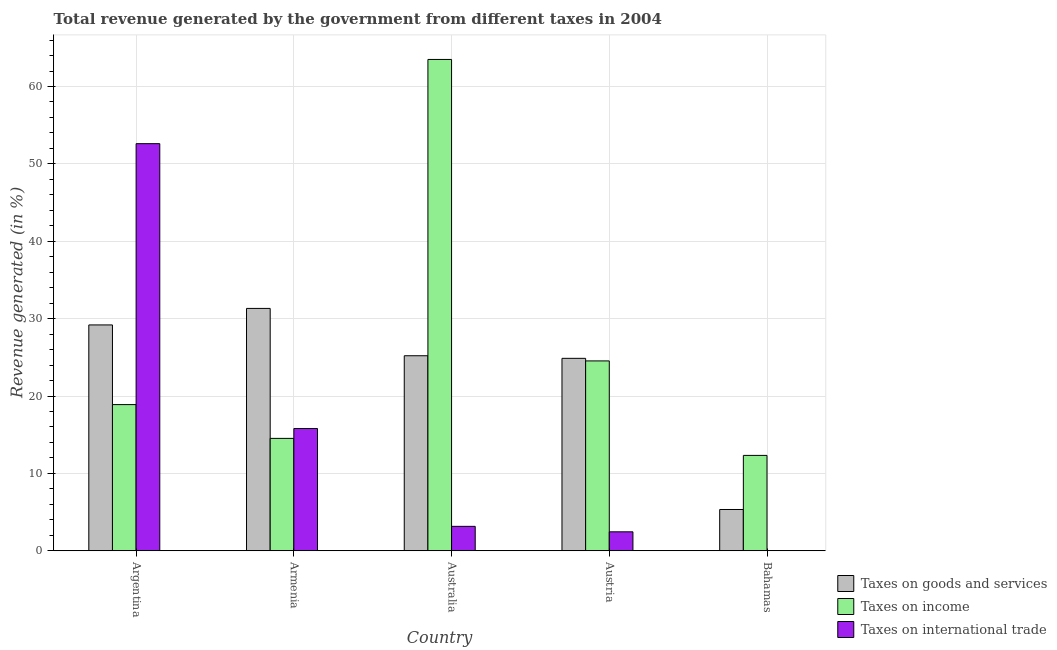How many different coloured bars are there?
Provide a short and direct response. 3. How many groups of bars are there?
Provide a short and direct response. 5. Are the number of bars per tick equal to the number of legend labels?
Offer a very short reply. Yes. Are the number of bars on each tick of the X-axis equal?
Your response must be concise. Yes. How many bars are there on the 3rd tick from the left?
Provide a succinct answer. 3. What is the label of the 2nd group of bars from the left?
Keep it short and to the point. Armenia. In how many cases, is the number of bars for a given country not equal to the number of legend labels?
Ensure brevity in your answer.  0. What is the percentage of revenue generated by taxes on income in Bahamas?
Give a very brief answer. 12.33. Across all countries, what is the maximum percentage of revenue generated by taxes on goods and services?
Provide a succinct answer. 31.32. Across all countries, what is the minimum percentage of revenue generated by taxes on goods and services?
Ensure brevity in your answer.  5.33. In which country was the percentage of revenue generated by taxes on income minimum?
Keep it short and to the point. Bahamas. What is the total percentage of revenue generated by tax on international trade in the graph?
Provide a short and direct response. 74.02. What is the difference between the percentage of revenue generated by taxes on goods and services in Armenia and that in Austria?
Keep it short and to the point. 6.45. What is the difference between the percentage of revenue generated by taxes on income in Australia and the percentage of revenue generated by tax on international trade in Argentina?
Offer a very short reply. 10.88. What is the average percentage of revenue generated by taxes on goods and services per country?
Your response must be concise. 23.18. What is the difference between the percentage of revenue generated by tax on international trade and percentage of revenue generated by taxes on income in Austria?
Make the answer very short. -22.09. What is the ratio of the percentage of revenue generated by taxes on income in Australia to that in Austria?
Make the answer very short. 2.59. Is the difference between the percentage of revenue generated by taxes on income in Argentina and Austria greater than the difference between the percentage of revenue generated by tax on international trade in Argentina and Austria?
Provide a succinct answer. No. What is the difference between the highest and the second highest percentage of revenue generated by tax on international trade?
Your response must be concise. 36.81. What is the difference between the highest and the lowest percentage of revenue generated by taxes on income?
Keep it short and to the point. 51.17. What does the 2nd bar from the left in Argentina represents?
Keep it short and to the point. Taxes on income. What does the 1st bar from the right in Austria represents?
Your response must be concise. Taxes on international trade. Is it the case that in every country, the sum of the percentage of revenue generated by taxes on goods and services and percentage of revenue generated by taxes on income is greater than the percentage of revenue generated by tax on international trade?
Your answer should be compact. No. How many bars are there?
Offer a terse response. 15. What is the difference between two consecutive major ticks on the Y-axis?
Give a very brief answer. 10. Are the values on the major ticks of Y-axis written in scientific E-notation?
Ensure brevity in your answer.  No. Does the graph contain any zero values?
Make the answer very short. No. Where does the legend appear in the graph?
Provide a succinct answer. Bottom right. What is the title of the graph?
Keep it short and to the point. Total revenue generated by the government from different taxes in 2004. What is the label or title of the X-axis?
Your response must be concise. Country. What is the label or title of the Y-axis?
Provide a short and direct response. Revenue generated (in %). What is the Revenue generated (in %) of Taxes on goods and services in Argentina?
Make the answer very short. 29.19. What is the Revenue generated (in %) of Taxes on income in Argentina?
Give a very brief answer. 18.89. What is the Revenue generated (in %) in Taxes on international trade in Argentina?
Keep it short and to the point. 52.61. What is the Revenue generated (in %) in Taxes on goods and services in Armenia?
Make the answer very short. 31.32. What is the Revenue generated (in %) of Taxes on income in Armenia?
Your answer should be very brief. 14.52. What is the Revenue generated (in %) of Taxes on international trade in Armenia?
Offer a terse response. 15.8. What is the Revenue generated (in %) of Taxes on goods and services in Australia?
Give a very brief answer. 25.2. What is the Revenue generated (in %) of Taxes on income in Australia?
Your answer should be compact. 63.5. What is the Revenue generated (in %) of Taxes on international trade in Australia?
Your answer should be compact. 3.16. What is the Revenue generated (in %) of Taxes on goods and services in Austria?
Your answer should be compact. 24.87. What is the Revenue generated (in %) in Taxes on income in Austria?
Provide a short and direct response. 24.54. What is the Revenue generated (in %) of Taxes on international trade in Austria?
Provide a short and direct response. 2.45. What is the Revenue generated (in %) in Taxes on goods and services in Bahamas?
Ensure brevity in your answer.  5.33. What is the Revenue generated (in %) in Taxes on income in Bahamas?
Ensure brevity in your answer.  12.33. What is the Revenue generated (in %) in Taxes on international trade in Bahamas?
Give a very brief answer. 0. Across all countries, what is the maximum Revenue generated (in %) in Taxes on goods and services?
Provide a short and direct response. 31.32. Across all countries, what is the maximum Revenue generated (in %) in Taxes on income?
Your response must be concise. 63.5. Across all countries, what is the maximum Revenue generated (in %) of Taxes on international trade?
Give a very brief answer. 52.61. Across all countries, what is the minimum Revenue generated (in %) in Taxes on goods and services?
Make the answer very short. 5.33. Across all countries, what is the minimum Revenue generated (in %) of Taxes on income?
Your response must be concise. 12.33. Across all countries, what is the minimum Revenue generated (in %) in Taxes on international trade?
Provide a succinct answer. 0. What is the total Revenue generated (in %) of Taxes on goods and services in the graph?
Your answer should be very brief. 115.92. What is the total Revenue generated (in %) in Taxes on income in the graph?
Give a very brief answer. 133.77. What is the total Revenue generated (in %) in Taxes on international trade in the graph?
Make the answer very short. 74.02. What is the difference between the Revenue generated (in %) in Taxes on goods and services in Argentina and that in Armenia?
Ensure brevity in your answer.  -2.13. What is the difference between the Revenue generated (in %) in Taxes on income in Argentina and that in Armenia?
Provide a short and direct response. 4.37. What is the difference between the Revenue generated (in %) of Taxes on international trade in Argentina and that in Armenia?
Make the answer very short. 36.81. What is the difference between the Revenue generated (in %) in Taxes on goods and services in Argentina and that in Australia?
Keep it short and to the point. 3.98. What is the difference between the Revenue generated (in %) in Taxes on income in Argentina and that in Australia?
Your answer should be very brief. -44.61. What is the difference between the Revenue generated (in %) in Taxes on international trade in Argentina and that in Australia?
Offer a very short reply. 49.46. What is the difference between the Revenue generated (in %) in Taxes on goods and services in Argentina and that in Austria?
Offer a terse response. 4.32. What is the difference between the Revenue generated (in %) of Taxes on income in Argentina and that in Austria?
Provide a short and direct response. -5.65. What is the difference between the Revenue generated (in %) in Taxes on international trade in Argentina and that in Austria?
Provide a short and direct response. 50.16. What is the difference between the Revenue generated (in %) in Taxes on goods and services in Argentina and that in Bahamas?
Keep it short and to the point. 23.85. What is the difference between the Revenue generated (in %) in Taxes on income in Argentina and that in Bahamas?
Keep it short and to the point. 6.56. What is the difference between the Revenue generated (in %) of Taxes on international trade in Argentina and that in Bahamas?
Give a very brief answer. 52.61. What is the difference between the Revenue generated (in %) in Taxes on goods and services in Armenia and that in Australia?
Ensure brevity in your answer.  6.12. What is the difference between the Revenue generated (in %) in Taxes on income in Armenia and that in Australia?
Provide a short and direct response. -48.97. What is the difference between the Revenue generated (in %) of Taxes on international trade in Armenia and that in Australia?
Keep it short and to the point. 12.64. What is the difference between the Revenue generated (in %) of Taxes on goods and services in Armenia and that in Austria?
Keep it short and to the point. 6.45. What is the difference between the Revenue generated (in %) of Taxes on income in Armenia and that in Austria?
Make the answer very short. -10.01. What is the difference between the Revenue generated (in %) in Taxes on international trade in Armenia and that in Austria?
Offer a terse response. 13.35. What is the difference between the Revenue generated (in %) of Taxes on goods and services in Armenia and that in Bahamas?
Make the answer very short. 25.99. What is the difference between the Revenue generated (in %) in Taxes on income in Armenia and that in Bahamas?
Offer a terse response. 2.2. What is the difference between the Revenue generated (in %) in Taxes on international trade in Armenia and that in Bahamas?
Your answer should be very brief. 15.8. What is the difference between the Revenue generated (in %) of Taxes on goods and services in Australia and that in Austria?
Your answer should be compact. 0.33. What is the difference between the Revenue generated (in %) in Taxes on income in Australia and that in Austria?
Keep it short and to the point. 38.96. What is the difference between the Revenue generated (in %) of Taxes on international trade in Australia and that in Austria?
Offer a terse response. 0.71. What is the difference between the Revenue generated (in %) of Taxes on goods and services in Australia and that in Bahamas?
Your answer should be compact. 19.87. What is the difference between the Revenue generated (in %) of Taxes on income in Australia and that in Bahamas?
Ensure brevity in your answer.  51.17. What is the difference between the Revenue generated (in %) of Taxes on international trade in Australia and that in Bahamas?
Your answer should be compact. 3.15. What is the difference between the Revenue generated (in %) in Taxes on goods and services in Austria and that in Bahamas?
Keep it short and to the point. 19.54. What is the difference between the Revenue generated (in %) of Taxes on income in Austria and that in Bahamas?
Ensure brevity in your answer.  12.21. What is the difference between the Revenue generated (in %) of Taxes on international trade in Austria and that in Bahamas?
Your response must be concise. 2.45. What is the difference between the Revenue generated (in %) of Taxes on goods and services in Argentina and the Revenue generated (in %) of Taxes on income in Armenia?
Your answer should be very brief. 14.66. What is the difference between the Revenue generated (in %) in Taxes on goods and services in Argentina and the Revenue generated (in %) in Taxes on international trade in Armenia?
Offer a very short reply. 13.39. What is the difference between the Revenue generated (in %) in Taxes on income in Argentina and the Revenue generated (in %) in Taxes on international trade in Armenia?
Ensure brevity in your answer.  3.09. What is the difference between the Revenue generated (in %) in Taxes on goods and services in Argentina and the Revenue generated (in %) in Taxes on income in Australia?
Provide a succinct answer. -34.31. What is the difference between the Revenue generated (in %) in Taxes on goods and services in Argentina and the Revenue generated (in %) in Taxes on international trade in Australia?
Provide a succinct answer. 26.03. What is the difference between the Revenue generated (in %) of Taxes on income in Argentina and the Revenue generated (in %) of Taxes on international trade in Australia?
Your answer should be very brief. 15.73. What is the difference between the Revenue generated (in %) of Taxes on goods and services in Argentina and the Revenue generated (in %) of Taxes on income in Austria?
Make the answer very short. 4.65. What is the difference between the Revenue generated (in %) in Taxes on goods and services in Argentina and the Revenue generated (in %) in Taxes on international trade in Austria?
Your answer should be very brief. 26.74. What is the difference between the Revenue generated (in %) of Taxes on income in Argentina and the Revenue generated (in %) of Taxes on international trade in Austria?
Make the answer very short. 16.44. What is the difference between the Revenue generated (in %) in Taxes on goods and services in Argentina and the Revenue generated (in %) in Taxes on income in Bahamas?
Give a very brief answer. 16.86. What is the difference between the Revenue generated (in %) of Taxes on goods and services in Argentina and the Revenue generated (in %) of Taxes on international trade in Bahamas?
Provide a succinct answer. 29.18. What is the difference between the Revenue generated (in %) of Taxes on income in Argentina and the Revenue generated (in %) of Taxes on international trade in Bahamas?
Keep it short and to the point. 18.89. What is the difference between the Revenue generated (in %) of Taxes on goods and services in Armenia and the Revenue generated (in %) of Taxes on income in Australia?
Your answer should be compact. -32.18. What is the difference between the Revenue generated (in %) in Taxes on goods and services in Armenia and the Revenue generated (in %) in Taxes on international trade in Australia?
Provide a succinct answer. 28.17. What is the difference between the Revenue generated (in %) in Taxes on income in Armenia and the Revenue generated (in %) in Taxes on international trade in Australia?
Keep it short and to the point. 11.37. What is the difference between the Revenue generated (in %) in Taxes on goods and services in Armenia and the Revenue generated (in %) in Taxes on income in Austria?
Your response must be concise. 6.78. What is the difference between the Revenue generated (in %) of Taxes on goods and services in Armenia and the Revenue generated (in %) of Taxes on international trade in Austria?
Your answer should be compact. 28.87. What is the difference between the Revenue generated (in %) in Taxes on income in Armenia and the Revenue generated (in %) in Taxes on international trade in Austria?
Offer a very short reply. 12.07. What is the difference between the Revenue generated (in %) of Taxes on goods and services in Armenia and the Revenue generated (in %) of Taxes on income in Bahamas?
Provide a short and direct response. 19. What is the difference between the Revenue generated (in %) of Taxes on goods and services in Armenia and the Revenue generated (in %) of Taxes on international trade in Bahamas?
Provide a succinct answer. 31.32. What is the difference between the Revenue generated (in %) of Taxes on income in Armenia and the Revenue generated (in %) of Taxes on international trade in Bahamas?
Offer a very short reply. 14.52. What is the difference between the Revenue generated (in %) of Taxes on goods and services in Australia and the Revenue generated (in %) of Taxes on income in Austria?
Make the answer very short. 0.67. What is the difference between the Revenue generated (in %) in Taxes on goods and services in Australia and the Revenue generated (in %) in Taxes on international trade in Austria?
Give a very brief answer. 22.75. What is the difference between the Revenue generated (in %) of Taxes on income in Australia and the Revenue generated (in %) of Taxes on international trade in Austria?
Offer a very short reply. 61.05. What is the difference between the Revenue generated (in %) in Taxes on goods and services in Australia and the Revenue generated (in %) in Taxes on income in Bahamas?
Offer a very short reply. 12.88. What is the difference between the Revenue generated (in %) of Taxes on goods and services in Australia and the Revenue generated (in %) of Taxes on international trade in Bahamas?
Provide a succinct answer. 25.2. What is the difference between the Revenue generated (in %) in Taxes on income in Australia and the Revenue generated (in %) in Taxes on international trade in Bahamas?
Keep it short and to the point. 63.49. What is the difference between the Revenue generated (in %) in Taxes on goods and services in Austria and the Revenue generated (in %) in Taxes on income in Bahamas?
Keep it short and to the point. 12.54. What is the difference between the Revenue generated (in %) in Taxes on goods and services in Austria and the Revenue generated (in %) in Taxes on international trade in Bahamas?
Ensure brevity in your answer.  24.87. What is the difference between the Revenue generated (in %) of Taxes on income in Austria and the Revenue generated (in %) of Taxes on international trade in Bahamas?
Keep it short and to the point. 24.53. What is the average Revenue generated (in %) of Taxes on goods and services per country?
Your answer should be compact. 23.18. What is the average Revenue generated (in %) of Taxes on income per country?
Make the answer very short. 26.75. What is the average Revenue generated (in %) in Taxes on international trade per country?
Keep it short and to the point. 14.8. What is the difference between the Revenue generated (in %) in Taxes on goods and services and Revenue generated (in %) in Taxes on income in Argentina?
Offer a terse response. 10.3. What is the difference between the Revenue generated (in %) in Taxes on goods and services and Revenue generated (in %) in Taxes on international trade in Argentina?
Make the answer very short. -23.43. What is the difference between the Revenue generated (in %) of Taxes on income and Revenue generated (in %) of Taxes on international trade in Argentina?
Your response must be concise. -33.72. What is the difference between the Revenue generated (in %) of Taxes on goods and services and Revenue generated (in %) of Taxes on income in Armenia?
Offer a terse response. 16.8. What is the difference between the Revenue generated (in %) in Taxes on goods and services and Revenue generated (in %) in Taxes on international trade in Armenia?
Make the answer very short. 15.52. What is the difference between the Revenue generated (in %) of Taxes on income and Revenue generated (in %) of Taxes on international trade in Armenia?
Your answer should be compact. -1.27. What is the difference between the Revenue generated (in %) in Taxes on goods and services and Revenue generated (in %) in Taxes on income in Australia?
Your answer should be compact. -38.29. What is the difference between the Revenue generated (in %) in Taxes on goods and services and Revenue generated (in %) in Taxes on international trade in Australia?
Keep it short and to the point. 22.05. What is the difference between the Revenue generated (in %) of Taxes on income and Revenue generated (in %) of Taxes on international trade in Australia?
Give a very brief answer. 60.34. What is the difference between the Revenue generated (in %) in Taxes on goods and services and Revenue generated (in %) in Taxes on income in Austria?
Provide a succinct answer. 0.33. What is the difference between the Revenue generated (in %) of Taxes on goods and services and Revenue generated (in %) of Taxes on international trade in Austria?
Provide a short and direct response. 22.42. What is the difference between the Revenue generated (in %) of Taxes on income and Revenue generated (in %) of Taxes on international trade in Austria?
Offer a very short reply. 22.09. What is the difference between the Revenue generated (in %) in Taxes on goods and services and Revenue generated (in %) in Taxes on income in Bahamas?
Ensure brevity in your answer.  -6.99. What is the difference between the Revenue generated (in %) of Taxes on goods and services and Revenue generated (in %) of Taxes on international trade in Bahamas?
Make the answer very short. 5.33. What is the difference between the Revenue generated (in %) in Taxes on income and Revenue generated (in %) in Taxes on international trade in Bahamas?
Your response must be concise. 12.32. What is the ratio of the Revenue generated (in %) of Taxes on goods and services in Argentina to that in Armenia?
Your answer should be very brief. 0.93. What is the ratio of the Revenue generated (in %) in Taxes on income in Argentina to that in Armenia?
Make the answer very short. 1.3. What is the ratio of the Revenue generated (in %) of Taxes on international trade in Argentina to that in Armenia?
Offer a very short reply. 3.33. What is the ratio of the Revenue generated (in %) in Taxes on goods and services in Argentina to that in Australia?
Ensure brevity in your answer.  1.16. What is the ratio of the Revenue generated (in %) of Taxes on income in Argentina to that in Australia?
Offer a very short reply. 0.3. What is the ratio of the Revenue generated (in %) of Taxes on international trade in Argentina to that in Australia?
Your answer should be compact. 16.67. What is the ratio of the Revenue generated (in %) in Taxes on goods and services in Argentina to that in Austria?
Ensure brevity in your answer.  1.17. What is the ratio of the Revenue generated (in %) of Taxes on income in Argentina to that in Austria?
Provide a short and direct response. 0.77. What is the ratio of the Revenue generated (in %) of Taxes on international trade in Argentina to that in Austria?
Your response must be concise. 21.47. What is the ratio of the Revenue generated (in %) in Taxes on goods and services in Argentina to that in Bahamas?
Offer a terse response. 5.47. What is the ratio of the Revenue generated (in %) of Taxes on income in Argentina to that in Bahamas?
Your answer should be very brief. 1.53. What is the ratio of the Revenue generated (in %) in Taxes on international trade in Argentina to that in Bahamas?
Your answer should be very brief. 1.21e+04. What is the ratio of the Revenue generated (in %) in Taxes on goods and services in Armenia to that in Australia?
Ensure brevity in your answer.  1.24. What is the ratio of the Revenue generated (in %) of Taxes on income in Armenia to that in Australia?
Give a very brief answer. 0.23. What is the ratio of the Revenue generated (in %) of Taxes on international trade in Armenia to that in Australia?
Offer a terse response. 5.01. What is the ratio of the Revenue generated (in %) of Taxes on goods and services in Armenia to that in Austria?
Provide a succinct answer. 1.26. What is the ratio of the Revenue generated (in %) of Taxes on income in Armenia to that in Austria?
Your answer should be very brief. 0.59. What is the ratio of the Revenue generated (in %) of Taxes on international trade in Armenia to that in Austria?
Keep it short and to the point. 6.45. What is the ratio of the Revenue generated (in %) of Taxes on goods and services in Armenia to that in Bahamas?
Your answer should be compact. 5.87. What is the ratio of the Revenue generated (in %) of Taxes on income in Armenia to that in Bahamas?
Offer a very short reply. 1.18. What is the ratio of the Revenue generated (in %) of Taxes on international trade in Armenia to that in Bahamas?
Make the answer very short. 3647.5. What is the ratio of the Revenue generated (in %) in Taxes on goods and services in Australia to that in Austria?
Keep it short and to the point. 1.01. What is the ratio of the Revenue generated (in %) in Taxes on income in Australia to that in Austria?
Your answer should be very brief. 2.59. What is the ratio of the Revenue generated (in %) of Taxes on international trade in Australia to that in Austria?
Keep it short and to the point. 1.29. What is the ratio of the Revenue generated (in %) of Taxes on goods and services in Australia to that in Bahamas?
Ensure brevity in your answer.  4.72. What is the ratio of the Revenue generated (in %) of Taxes on income in Australia to that in Bahamas?
Your answer should be very brief. 5.15. What is the ratio of the Revenue generated (in %) in Taxes on international trade in Australia to that in Bahamas?
Ensure brevity in your answer.  728.52. What is the ratio of the Revenue generated (in %) in Taxes on goods and services in Austria to that in Bahamas?
Your response must be concise. 4.66. What is the ratio of the Revenue generated (in %) of Taxes on income in Austria to that in Bahamas?
Your response must be concise. 1.99. What is the ratio of the Revenue generated (in %) of Taxes on international trade in Austria to that in Bahamas?
Your answer should be compact. 565.6. What is the difference between the highest and the second highest Revenue generated (in %) of Taxes on goods and services?
Offer a terse response. 2.13. What is the difference between the highest and the second highest Revenue generated (in %) of Taxes on income?
Ensure brevity in your answer.  38.96. What is the difference between the highest and the second highest Revenue generated (in %) in Taxes on international trade?
Ensure brevity in your answer.  36.81. What is the difference between the highest and the lowest Revenue generated (in %) of Taxes on goods and services?
Provide a succinct answer. 25.99. What is the difference between the highest and the lowest Revenue generated (in %) in Taxes on income?
Offer a very short reply. 51.17. What is the difference between the highest and the lowest Revenue generated (in %) of Taxes on international trade?
Offer a terse response. 52.61. 